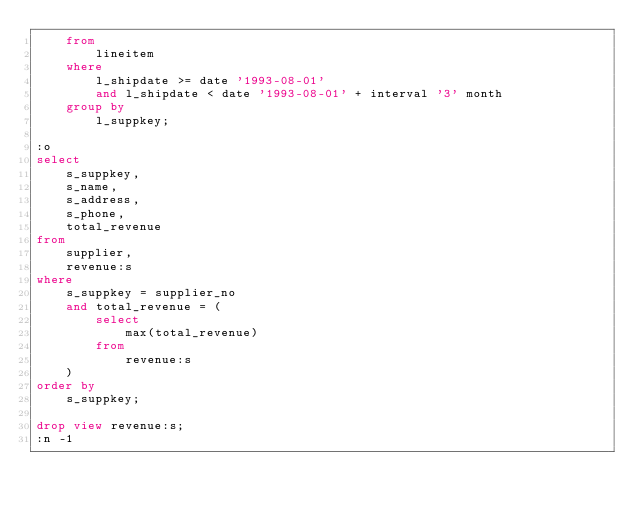<code> <loc_0><loc_0><loc_500><loc_500><_SQL_>	from
		lineitem
	where
		l_shipdate >= date '1993-08-01'
		and l_shipdate < date '1993-08-01' + interval '3' month
	group by
		l_suppkey;

:o
select
	s_suppkey,
	s_name,
	s_address,
	s_phone,
	total_revenue
from
	supplier,
	revenue:s
where
	s_suppkey = supplier_no
	and total_revenue = (
		select
			max(total_revenue)
		from
			revenue:s
	)
order by
	s_suppkey;

drop view revenue:s;
:n -1
</code> 